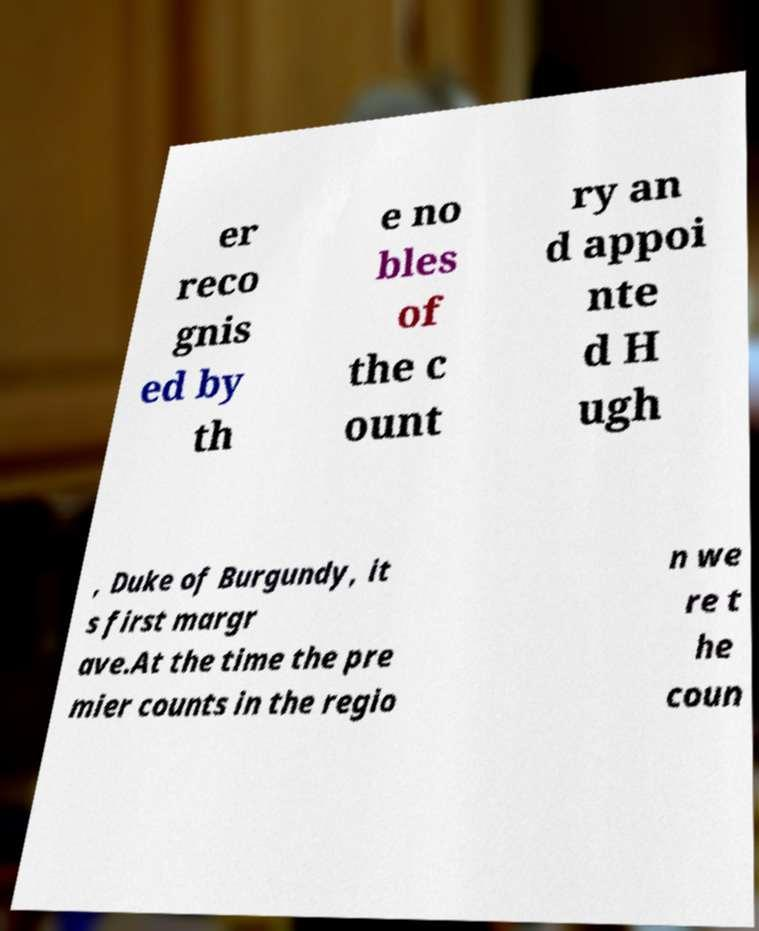I need the written content from this picture converted into text. Can you do that? er reco gnis ed by th e no bles of the c ount ry an d appoi nte d H ugh , Duke of Burgundy, it s first margr ave.At the time the pre mier counts in the regio n we re t he coun 